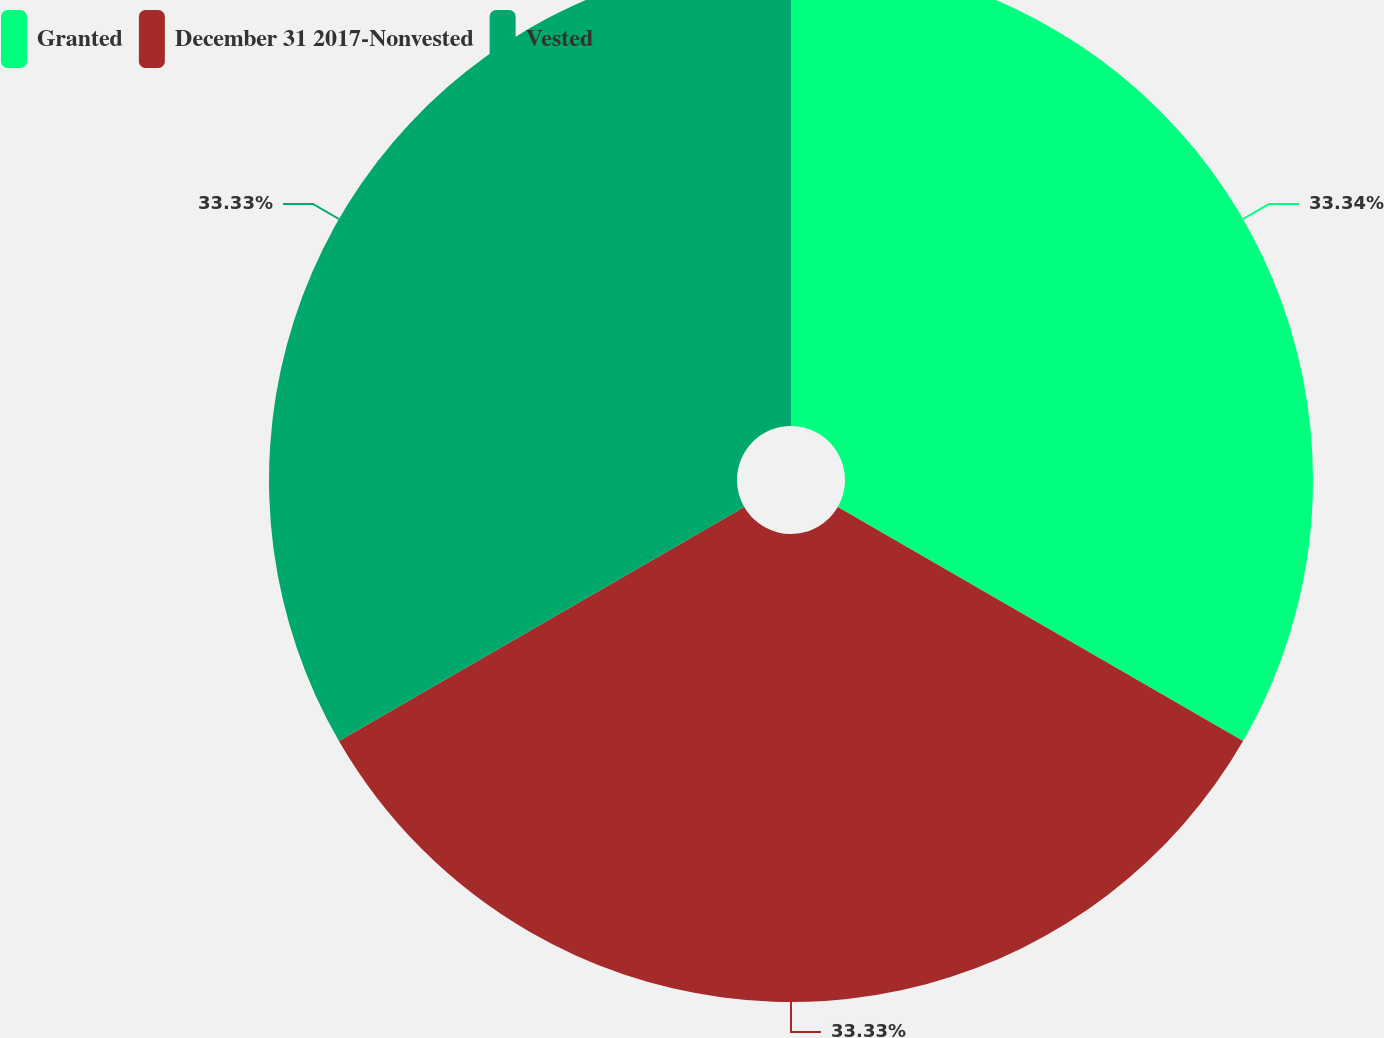Convert chart to OTSL. <chart><loc_0><loc_0><loc_500><loc_500><pie_chart><fcel>Granted<fcel>December 31 2017-Nonvested<fcel>Vested<nl><fcel>33.33%<fcel>33.33%<fcel>33.33%<nl></chart> 